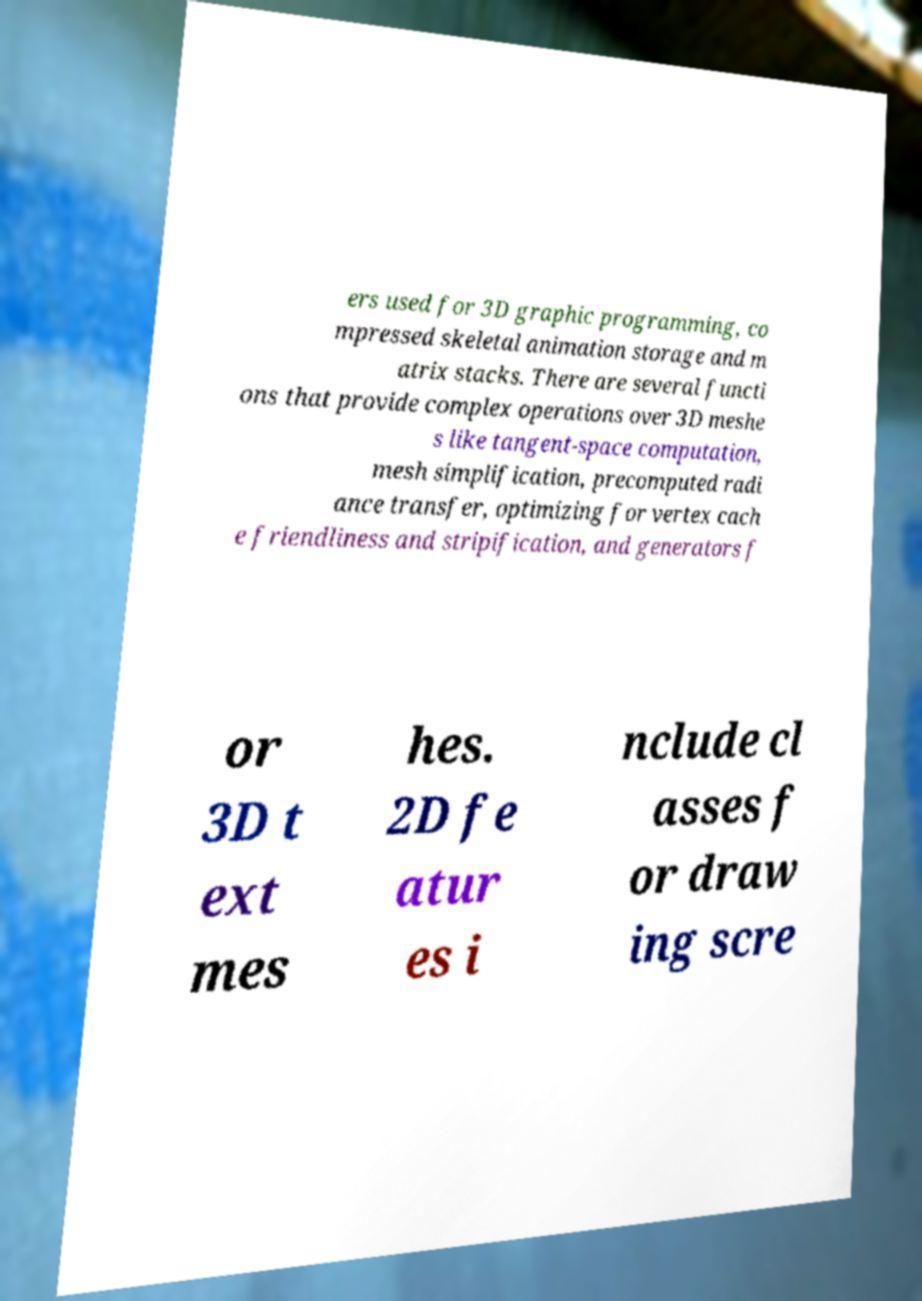Can you accurately transcribe the text from the provided image for me? ers used for 3D graphic programming, co mpressed skeletal animation storage and m atrix stacks. There are several functi ons that provide complex operations over 3D meshe s like tangent-space computation, mesh simplification, precomputed radi ance transfer, optimizing for vertex cach e friendliness and stripification, and generators f or 3D t ext mes hes. 2D fe atur es i nclude cl asses f or draw ing scre 